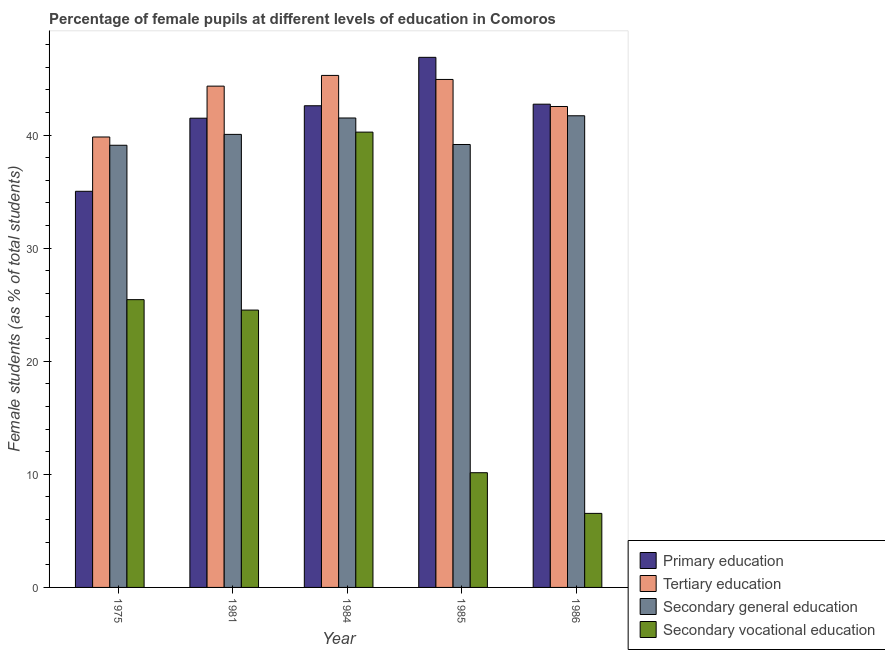How many different coloured bars are there?
Provide a succinct answer. 4. Are the number of bars on each tick of the X-axis equal?
Provide a succinct answer. Yes. How many bars are there on the 3rd tick from the left?
Ensure brevity in your answer.  4. How many bars are there on the 4th tick from the right?
Give a very brief answer. 4. What is the label of the 1st group of bars from the left?
Your response must be concise. 1975. What is the percentage of female students in tertiary education in 1984?
Keep it short and to the point. 45.28. Across all years, what is the maximum percentage of female students in tertiary education?
Make the answer very short. 45.28. Across all years, what is the minimum percentage of female students in secondary vocational education?
Your response must be concise. 6.55. In which year was the percentage of female students in primary education maximum?
Offer a terse response. 1985. In which year was the percentage of female students in secondary vocational education minimum?
Keep it short and to the point. 1986. What is the total percentage of female students in secondary education in the graph?
Make the answer very short. 201.56. What is the difference between the percentage of female students in primary education in 1975 and that in 1986?
Offer a very short reply. -7.7. What is the difference between the percentage of female students in tertiary education in 1985 and the percentage of female students in secondary education in 1975?
Keep it short and to the point. 5.09. What is the average percentage of female students in secondary education per year?
Offer a terse response. 40.31. In the year 1985, what is the difference between the percentage of female students in primary education and percentage of female students in secondary vocational education?
Ensure brevity in your answer.  0. In how many years, is the percentage of female students in secondary education greater than 42 %?
Provide a succinct answer. 0. What is the ratio of the percentage of female students in secondary vocational education in 1975 to that in 1981?
Make the answer very short. 1.04. Is the difference between the percentage of female students in secondary vocational education in 1981 and 1985 greater than the difference between the percentage of female students in primary education in 1981 and 1985?
Ensure brevity in your answer.  No. What is the difference between the highest and the second highest percentage of female students in secondary vocational education?
Give a very brief answer. 14.82. What is the difference between the highest and the lowest percentage of female students in secondary vocational education?
Offer a very short reply. 33.72. Is the sum of the percentage of female students in secondary vocational education in 1975 and 1981 greater than the maximum percentage of female students in secondary education across all years?
Make the answer very short. Yes. What does the 2nd bar from the left in 1981 represents?
Provide a succinct answer. Tertiary education. What does the 1st bar from the right in 1981 represents?
Keep it short and to the point. Secondary vocational education. How many bars are there?
Keep it short and to the point. 20. Are all the bars in the graph horizontal?
Offer a terse response. No. Are the values on the major ticks of Y-axis written in scientific E-notation?
Offer a very short reply. No. Does the graph contain any zero values?
Offer a terse response. No. Where does the legend appear in the graph?
Provide a short and direct response. Bottom right. How are the legend labels stacked?
Your answer should be compact. Vertical. What is the title of the graph?
Your answer should be very brief. Percentage of female pupils at different levels of education in Comoros. What is the label or title of the Y-axis?
Provide a short and direct response. Female students (as % of total students). What is the Female students (as % of total students) of Primary education in 1975?
Provide a short and direct response. 35.03. What is the Female students (as % of total students) in Tertiary education in 1975?
Your answer should be very brief. 39.83. What is the Female students (as % of total students) in Secondary general education in 1975?
Your answer should be very brief. 39.1. What is the Female students (as % of total students) of Secondary vocational education in 1975?
Keep it short and to the point. 25.45. What is the Female students (as % of total students) in Primary education in 1981?
Offer a very short reply. 41.5. What is the Female students (as % of total students) in Tertiary education in 1981?
Provide a succinct answer. 44.33. What is the Female students (as % of total students) in Secondary general education in 1981?
Give a very brief answer. 40.06. What is the Female students (as % of total students) in Secondary vocational education in 1981?
Your response must be concise. 24.53. What is the Female students (as % of total students) of Primary education in 1984?
Your answer should be compact. 42.6. What is the Female students (as % of total students) of Tertiary education in 1984?
Ensure brevity in your answer.  45.28. What is the Female students (as % of total students) of Secondary general education in 1984?
Provide a succinct answer. 41.51. What is the Female students (as % of total students) in Secondary vocational education in 1984?
Offer a terse response. 40.27. What is the Female students (as % of total students) in Primary education in 1985?
Provide a short and direct response. 46.88. What is the Female students (as % of total students) in Tertiary education in 1985?
Your answer should be compact. 44.92. What is the Female students (as % of total students) of Secondary general education in 1985?
Your answer should be very brief. 39.17. What is the Female students (as % of total students) in Secondary vocational education in 1985?
Make the answer very short. 10.14. What is the Female students (as % of total students) in Primary education in 1986?
Make the answer very short. 42.73. What is the Female students (as % of total students) in Tertiary education in 1986?
Offer a terse response. 42.53. What is the Female students (as % of total students) of Secondary general education in 1986?
Offer a very short reply. 41.71. What is the Female students (as % of total students) of Secondary vocational education in 1986?
Make the answer very short. 6.55. Across all years, what is the maximum Female students (as % of total students) of Primary education?
Keep it short and to the point. 46.88. Across all years, what is the maximum Female students (as % of total students) in Tertiary education?
Your answer should be very brief. 45.28. Across all years, what is the maximum Female students (as % of total students) in Secondary general education?
Keep it short and to the point. 41.71. Across all years, what is the maximum Female students (as % of total students) of Secondary vocational education?
Ensure brevity in your answer.  40.27. Across all years, what is the minimum Female students (as % of total students) of Primary education?
Your answer should be compact. 35.03. Across all years, what is the minimum Female students (as % of total students) of Tertiary education?
Your answer should be very brief. 39.83. Across all years, what is the minimum Female students (as % of total students) of Secondary general education?
Offer a very short reply. 39.1. Across all years, what is the minimum Female students (as % of total students) of Secondary vocational education?
Offer a terse response. 6.55. What is the total Female students (as % of total students) in Primary education in the graph?
Offer a terse response. 208.74. What is the total Female students (as % of total students) of Tertiary education in the graph?
Offer a very short reply. 216.9. What is the total Female students (as % of total students) in Secondary general education in the graph?
Keep it short and to the point. 201.56. What is the total Female students (as % of total students) of Secondary vocational education in the graph?
Your answer should be compact. 106.94. What is the difference between the Female students (as % of total students) of Primary education in 1975 and that in 1981?
Your answer should be compact. -6.46. What is the difference between the Female students (as % of total students) in Tertiary education in 1975 and that in 1981?
Make the answer very short. -4.5. What is the difference between the Female students (as % of total students) of Secondary general education in 1975 and that in 1981?
Your answer should be compact. -0.96. What is the difference between the Female students (as % of total students) in Secondary vocational education in 1975 and that in 1981?
Keep it short and to the point. 0.92. What is the difference between the Female students (as % of total students) in Primary education in 1975 and that in 1984?
Provide a short and direct response. -7.56. What is the difference between the Female students (as % of total students) in Tertiary education in 1975 and that in 1984?
Your response must be concise. -5.45. What is the difference between the Female students (as % of total students) in Secondary general education in 1975 and that in 1984?
Provide a short and direct response. -2.41. What is the difference between the Female students (as % of total students) in Secondary vocational education in 1975 and that in 1984?
Your answer should be compact. -14.82. What is the difference between the Female students (as % of total students) in Primary education in 1975 and that in 1985?
Provide a succinct answer. -11.85. What is the difference between the Female students (as % of total students) of Tertiary education in 1975 and that in 1985?
Keep it short and to the point. -5.09. What is the difference between the Female students (as % of total students) of Secondary general education in 1975 and that in 1985?
Provide a short and direct response. -0.07. What is the difference between the Female students (as % of total students) of Secondary vocational education in 1975 and that in 1985?
Ensure brevity in your answer.  15.3. What is the difference between the Female students (as % of total students) of Primary education in 1975 and that in 1986?
Your answer should be very brief. -7.7. What is the difference between the Female students (as % of total students) of Tertiary education in 1975 and that in 1986?
Keep it short and to the point. -2.7. What is the difference between the Female students (as % of total students) of Secondary general education in 1975 and that in 1986?
Provide a succinct answer. -2.61. What is the difference between the Female students (as % of total students) in Secondary vocational education in 1975 and that in 1986?
Ensure brevity in your answer.  18.9. What is the difference between the Female students (as % of total students) in Primary education in 1981 and that in 1984?
Make the answer very short. -1.1. What is the difference between the Female students (as % of total students) of Tertiary education in 1981 and that in 1984?
Offer a terse response. -0.95. What is the difference between the Female students (as % of total students) of Secondary general education in 1981 and that in 1984?
Offer a terse response. -1.45. What is the difference between the Female students (as % of total students) in Secondary vocational education in 1981 and that in 1984?
Offer a very short reply. -15.74. What is the difference between the Female students (as % of total students) of Primary education in 1981 and that in 1985?
Give a very brief answer. -5.38. What is the difference between the Female students (as % of total students) in Tertiary education in 1981 and that in 1985?
Make the answer very short. -0.59. What is the difference between the Female students (as % of total students) in Secondary general education in 1981 and that in 1985?
Your answer should be compact. 0.89. What is the difference between the Female students (as % of total students) of Secondary vocational education in 1981 and that in 1985?
Give a very brief answer. 14.38. What is the difference between the Female students (as % of total students) in Primary education in 1981 and that in 1986?
Provide a succinct answer. -1.24. What is the difference between the Female students (as % of total students) of Tertiary education in 1981 and that in 1986?
Provide a short and direct response. 1.8. What is the difference between the Female students (as % of total students) in Secondary general education in 1981 and that in 1986?
Make the answer very short. -1.65. What is the difference between the Female students (as % of total students) of Secondary vocational education in 1981 and that in 1986?
Offer a terse response. 17.98. What is the difference between the Female students (as % of total students) in Primary education in 1984 and that in 1985?
Provide a short and direct response. -4.28. What is the difference between the Female students (as % of total students) of Tertiary education in 1984 and that in 1985?
Your answer should be very brief. 0.36. What is the difference between the Female students (as % of total students) in Secondary general education in 1984 and that in 1985?
Ensure brevity in your answer.  2.34. What is the difference between the Female students (as % of total students) in Secondary vocational education in 1984 and that in 1985?
Provide a succinct answer. 30.12. What is the difference between the Female students (as % of total students) in Primary education in 1984 and that in 1986?
Offer a very short reply. -0.14. What is the difference between the Female students (as % of total students) of Tertiary education in 1984 and that in 1986?
Your answer should be very brief. 2.75. What is the difference between the Female students (as % of total students) of Secondary general education in 1984 and that in 1986?
Keep it short and to the point. -0.2. What is the difference between the Female students (as % of total students) in Secondary vocational education in 1984 and that in 1986?
Offer a terse response. 33.72. What is the difference between the Female students (as % of total students) in Primary education in 1985 and that in 1986?
Provide a succinct answer. 4.14. What is the difference between the Female students (as % of total students) of Tertiary education in 1985 and that in 1986?
Your answer should be very brief. 2.39. What is the difference between the Female students (as % of total students) of Secondary general education in 1985 and that in 1986?
Give a very brief answer. -2.54. What is the difference between the Female students (as % of total students) in Secondary vocational education in 1985 and that in 1986?
Ensure brevity in your answer.  3.6. What is the difference between the Female students (as % of total students) in Primary education in 1975 and the Female students (as % of total students) in Tertiary education in 1981?
Ensure brevity in your answer.  -9.3. What is the difference between the Female students (as % of total students) of Primary education in 1975 and the Female students (as % of total students) of Secondary general education in 1981?
Ensure brevity in your answer.  -5.03. What is the difference between the Female students (as % of total students) of Primary education in 1975 and the Female students (as % of total students) of Secondary vocational education in 1981?
Your answer should be very brief. 10.5. What is the difference between the Female students (as % of total students) of Tertiary education in 1975 and the Female students (as % of total students) of Secondary general education in 1981?
Your response must be concise. -0.23. What is the difference between the Female students (as % of total students) of Tertiary education in 1975 and the Female students (as % of total students) of Secondary vocational education in 1981?
Offer a very short reply. 15.31. What is the difference between the Female students (as % of total students) of Secondary general education in 1975 and the Female students (as % of total students) of Secondary vocational education in 1981?
Your answer should be very brief. 14.57. What is the difference between the Female students (as % of total students) in Primary education in 1975 and the Female students (as % of total students) in Tertiary education in 1984?
Keep it short and to the point. -10.25. What is the difference between the Female students (as % of total students) of Primary education in 1975 and the Female students (as % of total students) of Secondary general education in 1984?
Your response must be concise. -6.48. What is the difference between the Female students (as % of total students) of Primary education in 1975 and the Female students (as % of total students) of Secondary vocational education in 1984?
Keep it short and to the point. -5.23. What is the difference between the Female students (as % of total students) of Tertiary education in 1975 and the Female students (as % of total students) of Secondary general education in 1984?
Offer a very short reply. -1.68. What is the difference between the Female students (as % of total students) in Tertiary education in 1975 and the Female students (as % of total students) in Secondary vocational education in 1984?
Make the answer very short. -0.43. What is the difference between the Female students (as % of total students) of Secondary general education in 1975 and the Female students (as % of total students) of Secondary vocational education in 1984?
Your response must be concise. -1.16. What is the difference between the Female students (as % of total students) in Primary education in 1975 and the Female students (as % of total students) in Tertiary education in 1985?
Provide a succinct answer. -9.89. What is the difference between the Female students (as % of total students) of Primary education in 1975 and the Female students (as % of total students) of Secondary general education in 1985?
Offer a terse response. -4.14. What is the difference between the Female students (as % of total students) in Primary education in 1975 and the Female students (as % of total students) in Secondary vocational education in 1985?
Ensure brevity in your answer.  24.89. What is the difference between the Female students (as % of total students) of Tertiary education in 1975 and the Female students (as % of total students) of Secondary general education in 1985?
Make the answer very short. 0.66. What is the difference between the Female students (as % of total students) of Tertiary education in 1975 and the Female students (as % of total students) of Secondary vocational education in 1985?
Give a very brief answer. 29.69. What is the difference between the Female students (as % of total students) in Secondary general education in 1975 and the Female students (as % of total students) in Secondary vocational education in 1985?
Your response must be concise. 28.96. What is the difference between the Female students (as % of total students) in Primary education in 1975 and the Female students (as % of total students) in Tertiary education in 1986?
Offer a very short reply. -7.5. What is the difference between the Female students (as % of total students) in Primary education in 1975 and the Female students (as % of total students) in Secondary general education in 1986?
Keep it short and to the point. -6.68. What is the difference between the Female students (as % of total students) in Primary education in 1975 and the Female students (as % of total students) in Secondary vocational education in 1986?
Your response must be concise. 28.48. What is the difference between the Female students (as % of total students) of Tertiary education in 1975 and the Female students (as % of total students) of Secondary general education in 1986?
Your response must be concise. -1.88. What is the difference between the Female students (as % of total students) of Tertiary education in 1975 and the Female students (as % of total students) of Secondary vocational education in 1986?
Ensure brevity in your answer.  33.29. What is the difference between the Female students (as % of total students) in Secondary general education in 1975 and the Female students (as % of total students) in Secondary vocational education in 1986?
Provide a short and direct response. 32.55. What is the difference between the Female students (as % of total students) of Primary education in 1981 and the Female students (as % of total students) of Tertiary education in 1984?
Provide a short and direct response. -3.78. What is the difference between the Female students (as % of total students) in Primary education in 1981 and the Female students (as % of total students) in Secondary general education in 1984?
Your answer should be compact. -0.02. What is the difference between the Female students (as % of total students) of Primary education in 1981 and the Female students (as % of total students) of Secondary vocational education in 1984?
Your answer should be compact. 1.23. What is the difference between the Female students (as % of total students) in Tertiary education in 1981 and the Female students (as % of total students) in Secondary general education in 1984?
Ensure brevity in your answer.  2.82. What is the difference between the Female students (as % of total students) of Tertiary education in 1981 and the Female students (as % of total students) of Secondary vocational education in 1984?
Make the answer very short. 4.07. What is the difference between the Female students (as % of total students) in Secondary general education in 1981 and the Female students (as % of total students) in Secondary vocational education in 1984?
Offer a very short reply. -0.2. What is the difference between the Female students (as % of total students) in Primary education in 1981 and the Female students (as % of total students) in Tertiary education in 1985?
Keep it short and to the point. -3.43. What is the difference between the Female students (as % of total students) of Primary education in 1981 and the Female students (as % of total students) of Secondary general education in 1985?
Make the answer very short. 2.33. What is the difference between the Female students (as % of total students) of Primary education in 1981 and the Female students (as % of total students) of Secondary vocational education in 1985?
Offer a very short reply. 31.35. What is the difference between the Female students (as % of total students) of Tertiary education in 1981 and the Female students (as % of total students) of Secondary general education in 1985?
Provide a succinct answer. 5.16. What is the difference between the Female students (as % of total students) of Tertiary education in 1981 and the Female students (as % of total students) of Secondary vocational education in 1985?
Your response must be concise. 34.19. What is the difference between the Female students (as % of total students) in Secondary general education in 1981 and the Female students (as % of total students) in Secondary vocational education in 1985?
Keep it short and to the point. 29.92. What is the difference between the Female students (as % of total students) in Primary education in 1981 and the Female students (as % of total students) in Tertiary education in 1986?
Your answer should be very brief. -1.03. What is the difference between the Female students (as % of total students) in Primary education in 1981 and the Female students (as % of total students) in Secondary general education in 1986?
Your response must be concise. -0.21. What is the difference between the Female students (as % of total students) in Primary education in 1981 and the Female students (as % of total students) in Secondary vocational education in 1986?
Offer a very short reply. 34.95. What is the difference between the Female students (as % of total students) in Tertiary education in 1981 and the Female students (as % of total students) in Secondary general education in 1986?
Give a very brief answer. 2.62. What is the difference between the Female students (as % of total students) in Tertiary education in 1981 and the Female students (as % of total students) in Secondary vocational education in 1986?
Your response must be concise. 37.78. What is the difference between the Female students (as % of total students) of Secondary general education in 1981 and the Female students (as % of total students) of Secondary vocational education in 1986?
Offer a very short reply. 33.52. What is the difference between the Female students (as % of total students) of Primary education in 1984 and the Female students (as % of total students) of Tertiary education in 1985?
Offer a terse response. -2.33. What is the difference between the Female students (as % of total students) in Primary education in 1984 and the Female students (as % of total students) in Secondary general education in 1985?
Provide a short and direct response. 3.43. What is the difference between the Female students (as % of total students) in Primary education in 1984 and the Female students (as % of total students) in Secondary vocational education in 1985?
Your answer should be compact. 32.45. What is the difference between the Female students (as % of total students) in Tertiary education in 1984 and the Female students (as % of total students) in Secondary general education in 1985?
Provide a succinct answer. 6.11. What is the difference between the Female students (as % of total students) of Tertiary education in 1984 and the Female students (as % of total students) of Secondary vocational education in 1985?
Your answer should be very brief. 35.13. What is the difference between the Female students (as % of total students) in Secondary general education in 1984 and the Female students (as % of total students) in Secondary vocational education in 1985?
Provide a short and direct response. 31.37. What is the difference between the Female students (as % of total students) of Primary education in 1984 and the Female students (as % of total students) of Tertiary education in 1986?
Offer a very short reply. 0.06. What is the difference between the Female students (as % of total students) in Primary education in 1984 and the Female students (as % of total students) in Secondary general education in 1986?
Your answer should be compact. 0.89. What is the difference between the Female students (as % of total students) in Primary education in 1984 and the Female students (as % of total students) in Secondary vocational education in 1986?
Offer a terse response. 36.05. What is the difference between the Female students (as % of total students) of Tertiary education in 1984 and the Female students (as % of total students) of Secondary general education in 1986?
Offer a very short reply. 3.57. What is the difference between the Female students (as % of total students) in Tertiary education in 1984 and the Female students (as % of total students) in Secondary vocational education in 1986?
Give a very brief answer. 38.73. What is the difference between the Female students (as % of total students) of Secondary general education in 1984 and the Female students (as % of total students) of Secondary vocational education in 1986?
Provide a succinct answer. 34.97. What is the difference between the Female students (as % of total students) of Primary education in 1985 and the Female students (as % of total students) of Tertiary education in 1986?
Ensure brevity in your answer.  4.35. What is the difference between the Female students (as % of total students) in Primary education in 1985 and the Female students (as % of total students) in Secondary general education in 1986?
Provide a short and direct response. 5.17. What is the difference between the Female students (as % of total students) of Primary education in 1985 and the Female students (as % of total students) of Secondary vocational education in 1986?
Offer a very short reply. 40.33. What is the difference between the Female students (as % of total students) of Tertiary education in 1985 and the Female students (as % of total students) of Secondary general education in 1986?
Ensure brevity in your answer.  3.21. What is the difference between the Female students (as % of total students) of Tertiary education in 1985 and the Female students (as % of total students) of Secondary vocational education in 1986?
Your answer should be very brief. 38.38. What is the difference between the Female students (as % of total students) of Secondary general education in 1985 and the Female students (as % of total students) of Secondary vocational education in 1986?
Your answer should be very brief. 32.62. What is the average Female students (as % of total students) of Primary education per year?
Offer a terse response. 41.75. What is the average Female students (as % of total students) of Tertiary education per year?
Make the answer very short. 43.38. What is the average Female students (as % of total students) of Secondary general education per year?
Make the answer very short. 40.31. What is the average Female students (as % of total students) in Secondary vocational education per year?
Offer a terse response. 21.39. In the year 1975, what is the difference between the Female students (as % of total students) in Primary education and Female students (as % of total students) in Tertiary education?
Make the answer very short. -4.8. In the year 1975, what is the difference between the Female students (as % of total students) in Primary education and Female students (as % of total students) in Secondary general education?
Your response must be concise. -4.07. In the year 1975, what is the difference between the Female students (as % of total students) in Primary education and Female students (as % of total students) in Secondary vocational education?
Offer a terse response. 9.58. In the year 1975, what is the difference between the Female students (as % of total students) of Tertiary education and Female students (as % of total students) of Secondary general education?
Make the answer very short. 0.73. In the year 1975, what is the difference between the Female students (as % of total students) of Tertiary education and Female students (as % of total students) of Secondary vocational education?
Give a very brief answer. 14.38. In the year 1975, what is the difference between the Female students (as % of total students) of Secondary general education and Female students (as % of total students) of Secondary vocational education?
Ensure brevity in your answer.  13.65. In the year 1981, what is the difference between the Female students (as % of total students) in Primary education and Female students (as % of total students) in Tertiary education?
Keep it short and to the point. -2.83. In the year 1981, what is the difference between the Female students (as % of total students) in Primary education and Female students (as % of total students) in Secondary general education?
Offer a terse response. 1.43. In the year 1981, what is the difference between the Female students (as % of total students) of Primary education and Female students (as % of total students) of Secondary vocational education?
Your answer should be compact. 16.97. In the year 1981, what is the difference between the Female students (as % of total students) of Tertiary education and Female students (as % of total students) of Secondary general education?
Make the answer very short. 4.27. In the year 1981, what is the difference between the Female students (as % of total students) of Tertiary education and Female students (as % of total students) of Secondary vocational education?
Provide a succinct answer. 19.8. In the year 1981, what is the difference between the Female students (as % of total students) in Secondary general education and Female students (as % of total students) in Secondary vocational education?
Offer a terse response. 15.54. In the year 1984, what is the difference between the Female students (as % of total students) of Primary education and Female students (as % of total students) of Tertiary education?
Keep it short and to the point. -2.68. In the year 1984, what is the difference between the Female students (as % of total students) in Primary education and Female students (as % of total students) in Secondary general education?
Your answer should be compact. 1.08. In the year 1984, what is the difference between the Female students (as % of total students) of Primary education and Female students (as % of total students) of Secondary vocational education?
Your response must be concise. 2.33. In the year 1984, what is the difference between the Female students (as % of total students) of Tertiary education and Female students (as % of total students) of Secondary general education?
Your answer should be very brief. 3.76. In the year 1984, what is the difference between the Female students (as % of total students) of Tertiary education and Female students (as % of total students) of Secondary vocational education?
Offer a very short reply. 5.01. In the year 1984, what is the difference between the Female students (as % of total students) in Secondary general education and Female students (as % of total students) in Secondary vocational education?
Keep it short and to the point. 1.25. In the year 1985, what is the difference between the Female students (as % of total students) of Primary education and Female students (as % of total students) of Tertiary education?
Ensure brevity in your answer.  1.96. In the year 1985, what is the difference between the Female students (as % of total students) of Primary education and Female students (as % of total students) of Secondary general education?
Provide a succinct answer. 7.71. In the year 1985, what is the difference between the Female students (as % of total students) in Primary education and Female students (as % of total students) in Secondary vocational education?
Offer a very short reply. 36.73. In the year 1985, what is the difference between the Female students (as % of total students) of Tertiary education and Female students (as % of total students) of Secondary general education?
Give a very brief answer. 5.75. In the year 1985, what is the difference between the Female students (as % of total students) in Tertiary education and Female students (as % of total students) in Secondary vocational education?
Your response must be concise. 34.78. In the year 1985, what is the difference between the Female students (as % of total students) of Secondary general education and Female students (as % of total students) of Secondary vocational education?
Ensure brevity in your answer.  29.03. In the year 1986, what is the difference between the Female students (as % of total students) of Primary education and Female students (as % of total students) of Tertiary education?
Your answer should be compact. 0.2. In the year 1986, what is the difference between the Female students (as % of total students) of Primary education and Female students (as % of total students) of Secondary general education?
Ensure brevity in your answer.  1.02. In the year 1986, what is the difference between the Female students (as % of total students) of Primary education and Female students (as % of total students) of Secondary vocational education?
Ensure brevity in your answer.  36.19. In the year 1986, what is the difference between the Female students (as % of total students) in Tertiary education and Female students (as % of total students) in Secondary general education?
Keep it short and to the point. 0.82. In the year 1986, what is the difference between the Female students (as % of total students) in Tertiary education and Female students (as % of total students) in Secondary vocational education?
Your response must be concise. 35.98. In the year 1986, what is the difference between the Female students (as % of total students) in Secondary general education and Female students (as % of total students) in Secondary vocational education?
Your response must be concise. 35.16. What is the ratio of the Female students (as % of total students) of Primary education in 1975 to that in 1981?
Your response must be concise. 0.84. What is the ratio of the Female students (as % of total students) in Tertiary education in 1975 to that in 1981?
Your answer should be compact. 0.9. What is the ratio of the Female students (as % of total students) in Secondary general education in 1975 to that in 1981?
Ensure brevity in your answer.  0.98. What is the ratio of the Female students (as % of total students) in Secondary vocational education in 1975 to that in 1981?
Make the answer very short. 1.04. What is the ratio of the Female students (as % of total students) in Primary education in 1975 to that in 1984?
Keep it short and to the point. 0.82. What is the ratio of the Female students (as % of total students) in Tertiary education in 1975 to that in 1984?
Offer a terse response. 0.88. What is the ratio of the Female students (as % of total students) in Secondary general education in 1975 to that in 1984?
Ensure brevity in your answer.  0.94. What is the ratio of the Female students (as % of total students) of Secondary vocational education in 1975 to that in 1984?
Provide a short and direct response. 0.63. What is the ratio of the Female students (as % of total students) in Primary education in 1975 to that in 1985?
Ensure brevity in your answer.  0.75. What is the ratio of the Female students (as % of total students) of Tertiary education in 1975 to that in 1985?
Keep it short and to the point. 0.89. What is the ratio of the Female students (as % of total students) in Secondary general education in 1975 to that in 1985?
Offer a very short reply. 1. What is the ratio of the Female students (as % of total students) of Secondary vocational education in 1975 to that in 1985?
Give a very brief answer. 2.51. What is the ratio of the Female students (as % of total students) in Primary education in 1975 to that in 1986?
Your response must be concise. 0.82. What is the ratio of the Female students (as % of total students) in Tertiary education in 1975 to that in 1986?
Provide a succinct answer. 0.94. What is the ratio of the Female students (as % of total students) of Secondary vocational education in 1975 to that in 1986?
Your response must be concise. 3.89. What is the ratio of the Female students (as % of total students) of Primary education in 1981 to that in 1984?
Provide a short and direct response. 0.97. What is the ratio of the Female students (as % of total students) of Tertiary education in 1981 to that in 1984?
Provide a succinct answer. 0.98. What is the ratio of the Female students (as % of total students) in Secondary general education in 1981 to that in 1984?
Your answer should be very brief. 0.97. What is the ratio of the Female students (as % of total students) of Secondary vocational education in 1981 to that in 1984?
Offer a very short reply. 0.61. What is the ratio of the Female students (as % of total students) of Primary education in 1981 to that in 1985?
Provide a short and direct response. 0.89. What is the ratio of the Female students (as % of total students) of Tertiary education in 1981 to that in 1985?
Keep it short and to the point. 0.99. What is the ratio of the Female students (as % of total students) of Secondary general education in 1981 to that in 1985?
Your answer should be compact. 1.02. What is the ratio of the Female students (as % of total students) of Secondary vocational education in 1981 to that in 1985?
Provide a succinct answer. 2.42. What is the ratio of the Female students (as % of total students) in Tertiary education in 1981 to that in 1986?
Make the answer very short. 1.04. What is the ratio of the Female students (as % of total students) of Secondary general education in 1981 to that in 1986?
Keep it short and to the point. 0.96. What is the ratio of the Female students (as % of total students) in Secondary vocational education in 1981 to that in 1986?
Offer a terse response. 3.75. What is the ratio of the Female students (as % of total students) in Primary education in 1984 to that in 1985?
Ensure brevity in your answer.  0.91. What is the ratio of the Female students (as % of total students) in Tertiary education in 1984 to that in 1985?
Offer a very short reply. 1.01. What is the ratio of the Female students (as % of total students) in Secondary general education in 1984 to that in 1985?
Provide a succinct answer. 1.06. What is the ratio of the Female students (as % of total students) of Secondary vocational education in 1984 to that in 1985?
Make the answer very short. 3.97. What is the ratio of the Female students (as % of total students) in Primary education in 1984 to that in 1986?
Offer a terse response. 1. What is the ratio of the Female students (as % of total students) in Tertiary education in 1984 to that in 1986?
Keep it short and to the point. 1.06. What is the ratio of the Female students (as % of total students) of Secondary vocational education in 1984 to that in 1986?
Keep it short and to the point. 6.15. What is the ratio of the Female students (as % of total students) of Primary education in 1985 to that in 1986?
Ensure brevity in your answer.  1.1. What is the ratio of the Female students (as % of total students) in Tertiary education in 1985 to that in 1986?
Your answer should be compact. 1.06. What is the ratio of the Female students (as % of total students) of Secondary general education in 1985 to that in 1986?
Offer a very short reply. 0.94. What is the ratio of the Female students (as % of total students) of Secondary vocational education in 1985 to that in 1986?
Provide a succinct answer. 1.55. What is the difference between the highest and the second highest Female students (as % of total students) of Primary education?
Give a very brief answer. 4.14. What is the difference between the highest and the second highest Female students (as % of total students) of Tertiary education?
Provide a succinct answer. 0.36. What is the difference between the highest and the second highest Female students (as % of total students) of Secondary general education?
Your answer should be very brief. 0.2. What is the difference between the highest and the second highest Female students (as % of total students) in Secondary vocational education?
Ensure brevity in your answer.  14.82. What is the difference between the highest and the lowest Female students (as % of total students) in Primary education?
Ensure brevity in your answer.  11.85. What is the difference between the highest and the lowest Female students (as % of total students) in Tertiary education?
Offer a very short reply. 5.45. What is the difference between the highest and the lowest Female students (as % of total students) of Secondary general education?
Your answer should be compact. 2.61. What is the difference between the highest and the lowest Female students (as % of total students) of Secondary vocational education?
Ensure brevity in your answer.  33.72. 